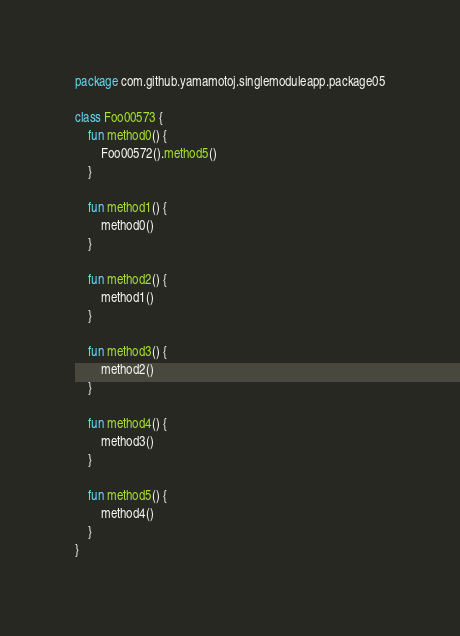<code> <loc_0><loc_0><loc_500><loc_500><_Kotlin_>package com.github.yamamotoj.singlemoduleapp.package05

class Foo00573 {
    fun method0() {
        Foo00572().method5()
    }

    fun method1() {
        method0()
    }

    fun method2() {
        method1()
    }

    fun method3() {
        method2()
    }

    fun method4() {
        method3()
    }

    fun method5() {
        method4()
    }
}
</code> 